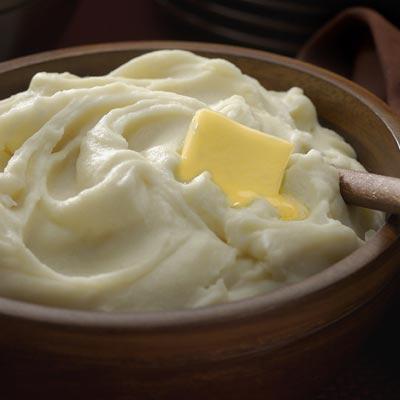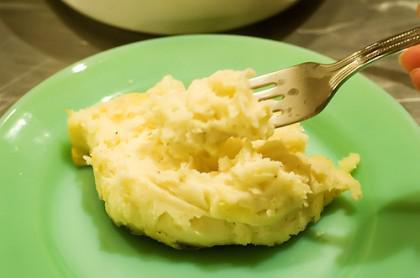The first image is the image on the left, the second image is the image on the right. Considering the images on both sides, is "In one of the images, there is a green topping." valid? Answer yes or no. No. The first image is the image on the left, the second image is the image on the right. For the images displayed, is the sentence "One imagine in the pair has a slab of butter visible in the mashed potato." factually correct? Answer yes or no. Yes. 